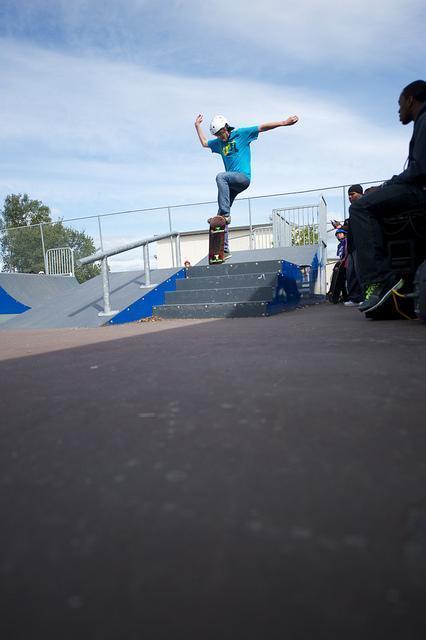How many people are there?
Give a very brief answer. 2. 